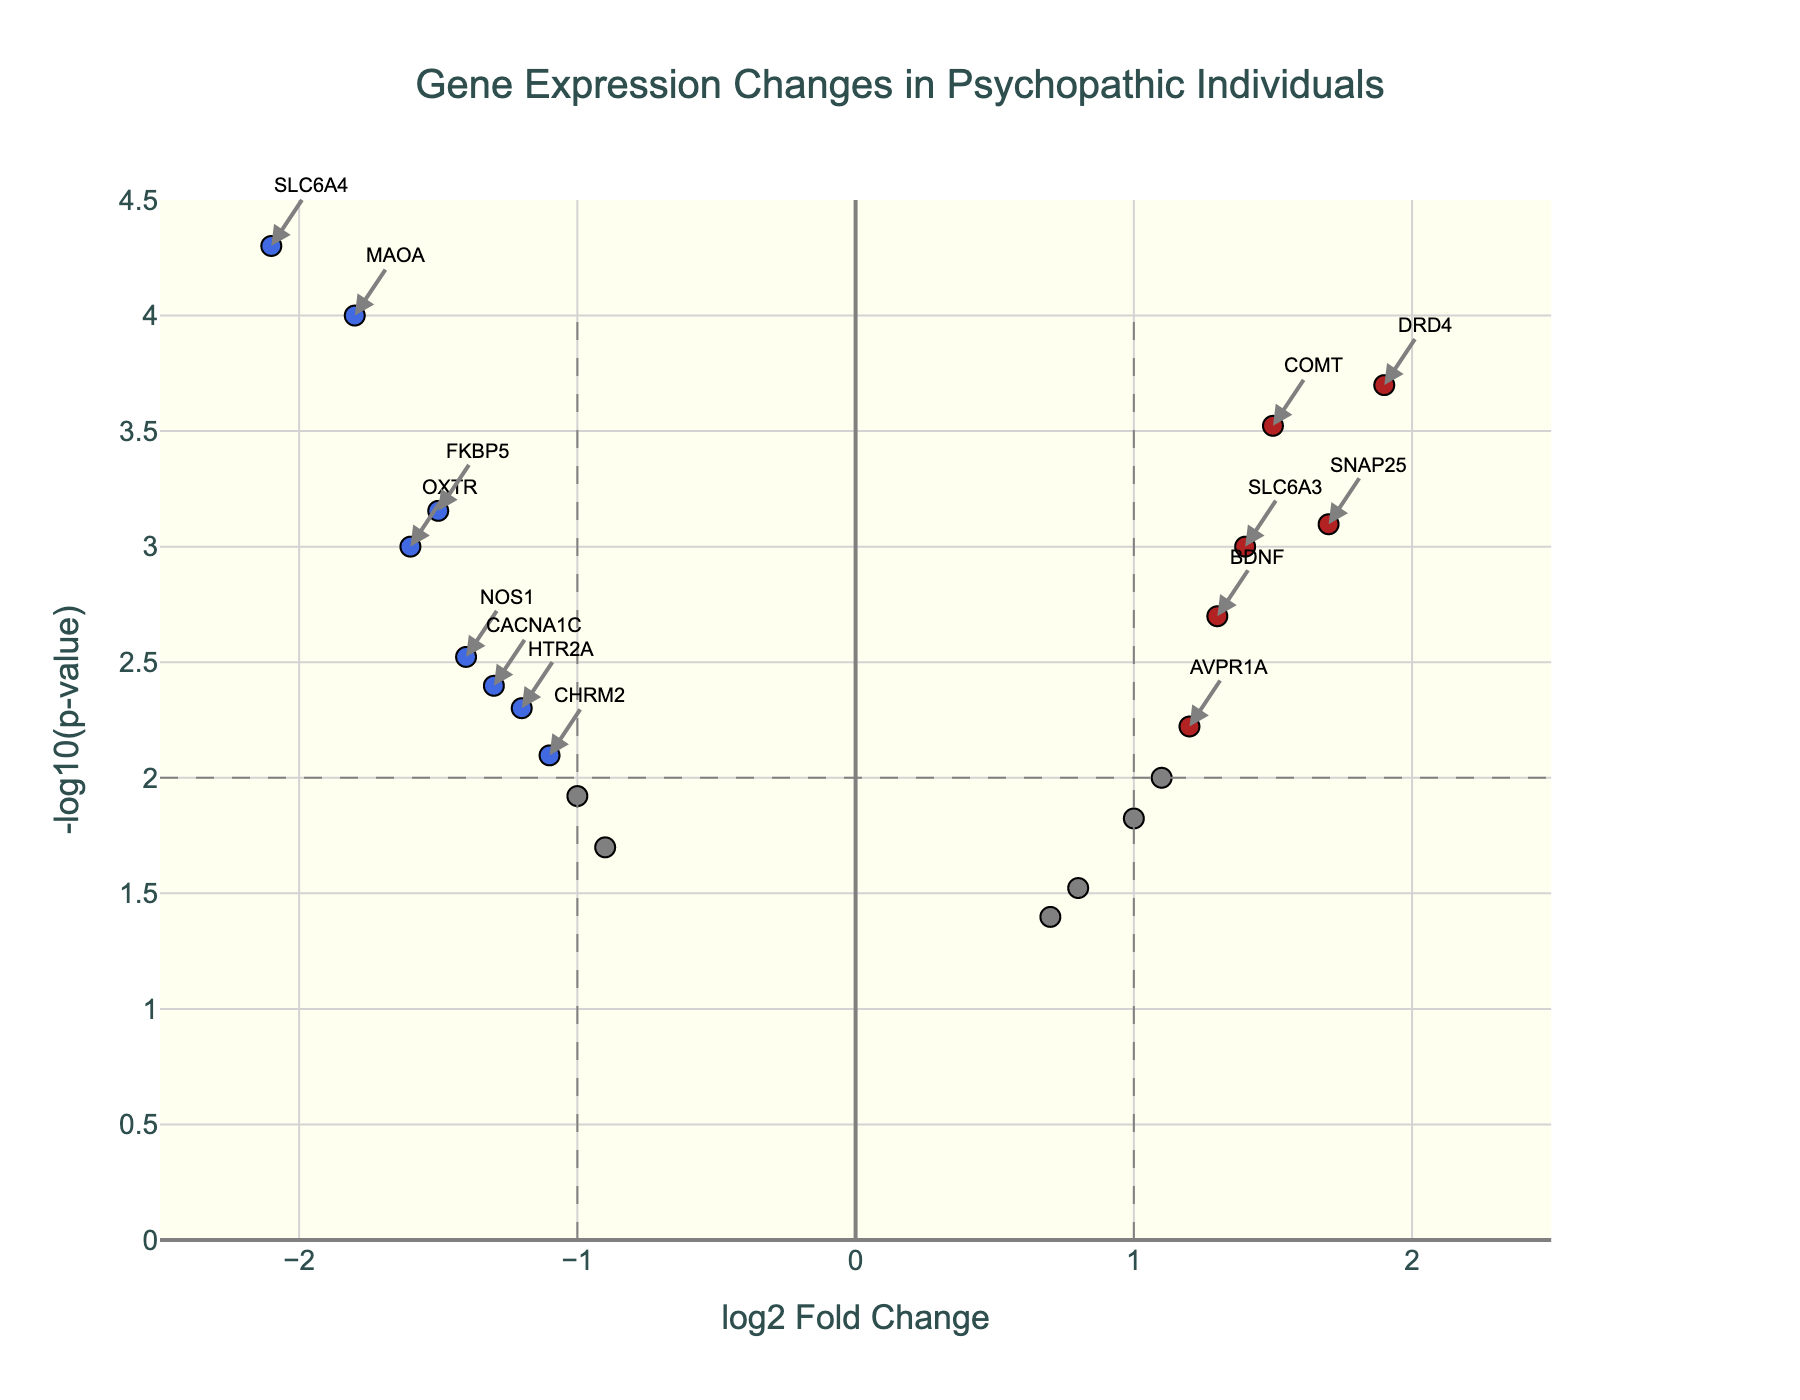What is the title of the figure? The title of the figure is displayed prominently at the top and provides a summary of what the plot represents. In this case, it is "Gene Expression Changes in Psychopathic Individuals."
Answer: Gene Expression Changes in Psychopathic Individuals How are significantly up-regulated and down-regulated genes visually represented in the plot? In the volcano plot, significantly up-regulated genes are represented by red-colored markers, while significantly down-regulated genes are represented by blue-colored markers. This is due to the color coding defined in the data processing step based on thresholds.
Answer: Red and Blue markers Which gene shows the highest log2 fold change among those significantly up-regulated? To determine this, locate the red markers (up-regulated genes) on the plot and identify the one farthest to the right on the x-axis. The gene with the highest log2 fold change is DRD4.
Answer: DRD4 What is the threshold for the log2 fold change, and how is it represented in the plot? The threshold for the log2 fold change is +/-1. This is represented by two vertical dashed gray lines at x = 1 and x = -1 on the plot.
Answer: +/-1 Are there more significantly up-regulated or down-regulated genes in the data? By counting the red and blue markers, we can see there are 4 significantly up-regulated (red) genes and 5 significantly down-regulated (blue) genes. Therefore, there are more significantly down-regulated genes.
Answer: More significantly down-regulated genes Which gene has the smallest p-value among significantly down-regulated genes, and what is its -log10(pValue)? To find this, look at the blue markers (down-regulated genes) and identify the one highest on the y-axis, as smaller p-values correspond to larger -log10(pValue). The gene is SLC6A4, with a -log10(pValue) around 4.3.
Answer: SLC6A4, 4.3 Which significantly up-regulated gene has the lowest -log10(pValue)? Among the red markers (up-regulated genes), find the one lowest on the y-axis. The gene AVPR1A, with a -log10(pValue) of approximately 2.22, has the lowest -log10(pValue) among significantly up-regulated genes.
Answer: AVPR1A What is the y-axis label, and what does it represent? The y-axis label is "-log10(p-value)," representing the negative logarithm (base 10) of the p-value for each gene, which helps emphasize smaller p-values visually by making them larger.
Answer: -log10(p-value) Which gene has a log2 fold change closest to zero but is still considered significant based on p-value? To find this, locate the markers nearest to the zero point on the x-axis and check which of them fall below the horizontal threshold line for p-value (gray dashed line at y = 2). The gene AVPR1A, with a log2 fold change of approximately 1.2 and a -log10(pValue) around 2.22, meets this criterion.
Answer: AVPR1A What does the colored marker at approximately (1.4, 3) represent in terms of gene, its log2FoldChange, and p-value? This marker represents the gene SLC6A3, with a log2FoldChange of 1.4 and a -log10(pValue) of roughly 3. This marker is red, indicating it is significantly up-regulated.
Answer: SLC6A3, log2FoldChange: 1.4, p-value: ~0.001 